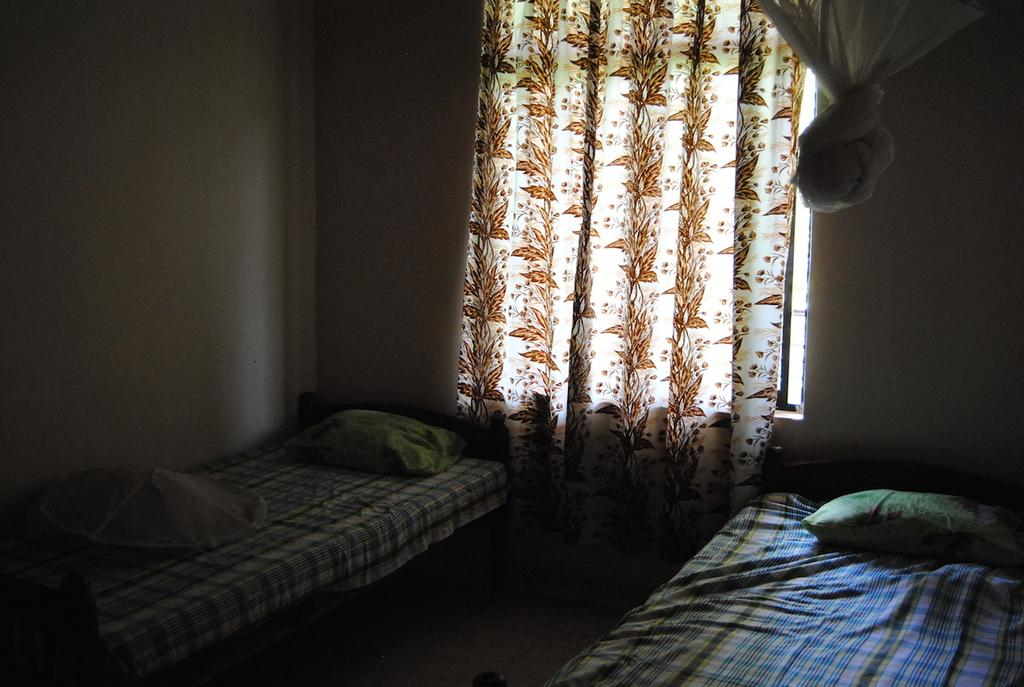How many beds are on the floor in the image? There are two beds on the floor in the image. What is placed on top of the beds? There are pillows on the beds. What is located behind the beds? There is a wall behind the beds. What type of window treatment is present in the image? There is a curtain on the wall. How many stars can be seen on the wall in the image? There are no stars visible on the wall in the image. 